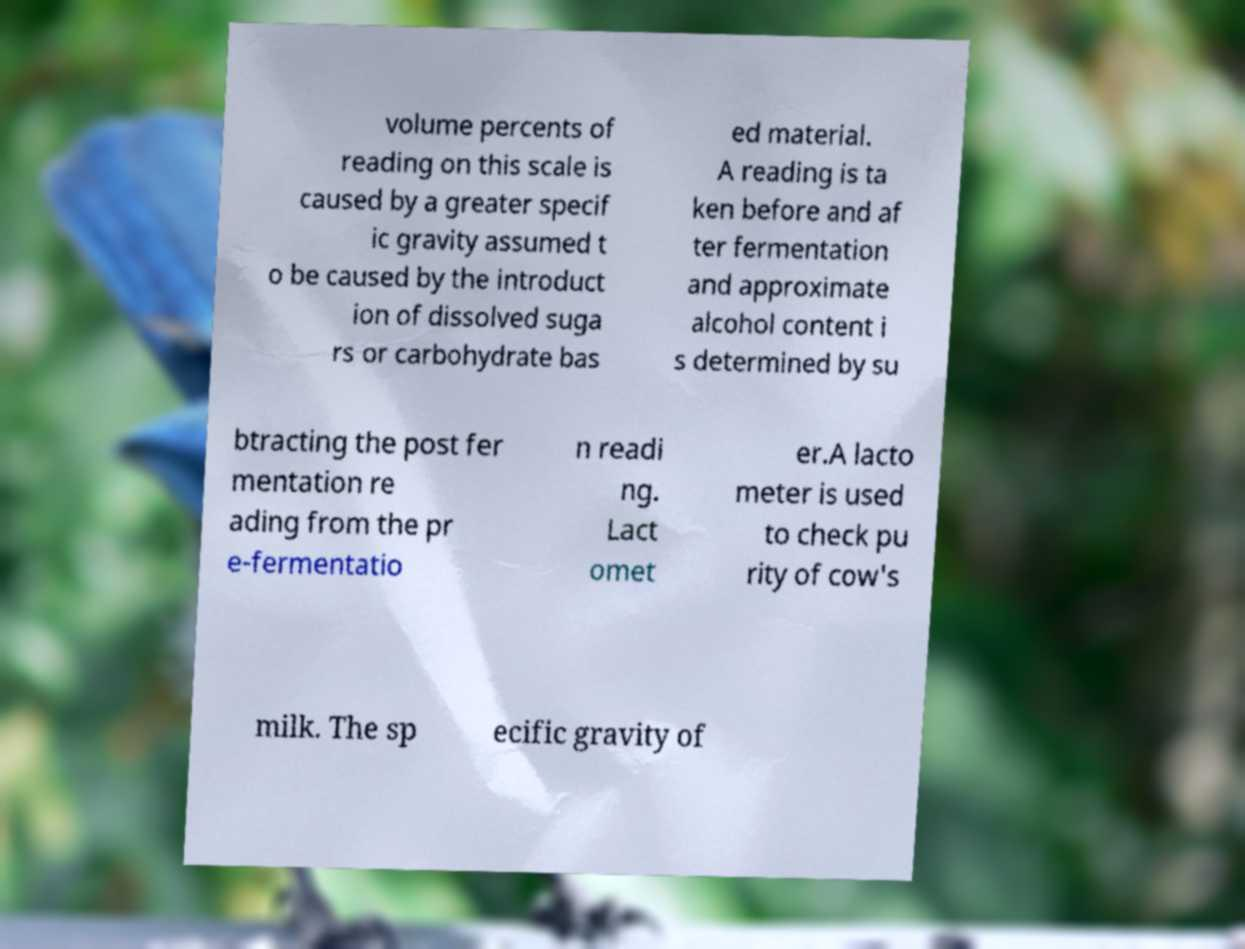Can you accurately transcribe the text from the provided image for me? volume percents of reading on this scale is caused by a greater specif ic gravity assumed t o be caused by the introduct ion of dissolved suga rs or carbohydrate bas ed material. A reading is ta ken before and af ter fermentation and approximate alcohol content i s determined by su btracting the post fer mentation re ading from the pr e-fermentatio n readi ng. Lact omet er.A lacto meter is used to check pu rity of cow's milk. The sp ecific gravity of 